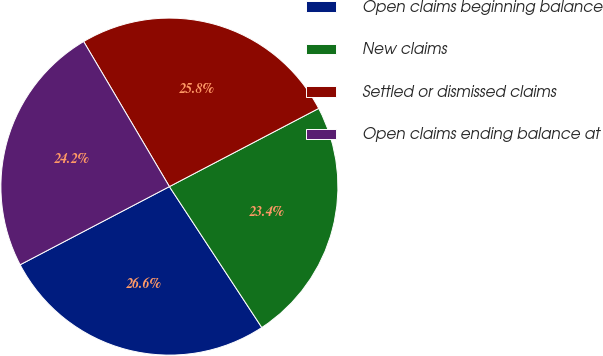Convert chart to OTSL. <chart><loc_0><loc_0><loc_500><loc_500><pie_chart><fcel>Open claims beginning balance<fcel>New claims<fcel>Settled or dismissed claims<fcel>Open claims ending balance at<nl><fcel>26.56%<fcel>23.44%<fcel>25.82%<fcel>24.18%<nl></chart> 